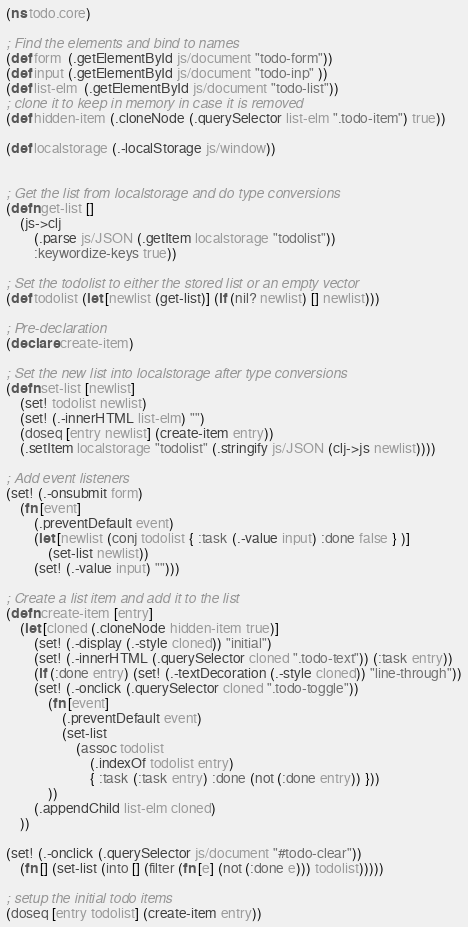Convert code to text. <code><loc_0><loc_0><loc_500><loc_500><_Clojure_>(ns todo.core)

; Find the elements and bind to names
(def form  (.getElementById js/document "todo-form"))
(def input (.getElementById js/document "todo-inp" ))
(def list-elm  (.getElementById js/document "todo-list"))
; clone it to keep in memory in case it is removed
(def hidden-item (.cloneNode (.querySelector list-elm ".todo-item") true))

(def localstorage (.-localStorage js/window))


; Get the list from localstorage and do type conversions
(defn get-list []
    (js->clj
        (.parse js/JSON (.getItem localstorage "todolist"))
        :keywordize-keys true))

; Set the todolist to either the stored list or an empty vector
(def todolist (let [newlist (get-list)] (if (nil? newlist) [] newlist)))

; Pre-declaration
(declare create-item)

; Set the new list into localstorage after type conversions
(defn set-list [newlist]
    (set! todolist newlist)
    (set! (.-innerHTML list-elm) "")
    (doseq [entry newlist] (create-item entry))
    (.setItem localstorage "todolist" (.stringify js/JSON (clj->js newlist))))

; Add event listeners
(set! (.-onsubmit form)
    (fn [event]
        (.preventDefault event)
        (let [newlist (conj todolist { :task (.-value input) :done false } )]
            (set-list newlist))
        (set! (.-value input) "")))

; Create a list item and add it to the list
(defn create-item [entry]
    (let [cloned (.cloneNode hidden-item true)]
        (set! (.-display (.-style cloned)) "initial")
        (set! (.-innerHTML (.querySelector cloned ".todo-text")) (:task entry))
        (if (:done entry) (set! (.-textDecoration (.-style cloned)) "line-through"))
        (set! (.-onclick (.querySelector cloned ".todo-toggle"))
            (fn [event]
                (.preventDefault event)
                (set-list
                    (assoc todolist
                        (.indexOf todolist entry)
                        { :task (:task entry) :done (not (:done entry)) }))
            ))
        (.appendChild list-elm cloned)
    ))

(set! (.-onclick (.querySelector js/document "#todo-clear"))
    (fn [] (set-list (into [] (filter (fn [e] (not (:done e))) todolist)))))

; setup the initial todo items
(doseq [entry todolist] (create-item entry))
</code> 